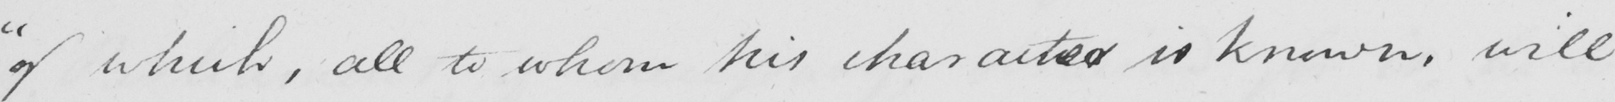What does this handwritten line say? " of which , all to whom his character is known , will 